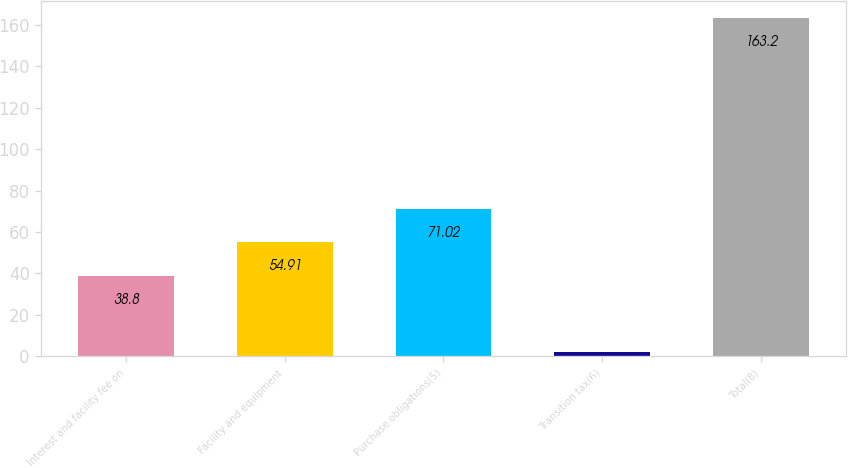<chart> <loc_0><loc_0><loc_500><loc_500><bar_chart><fcel>Interest and facility fee on<fcel>Facility and equipment<fcel>Purchase obligations(5)<fcel>Transition tax(6)<fcel>Total(8)<nl><fcel>38.8<fcel>54.91<fcel>71.02<fcel>2.1<fcel>163.2<nl></chart> 